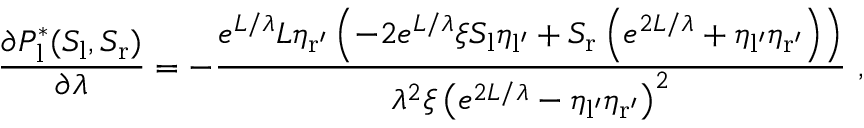Convert formula to latex. <formula><loc_0><loc_0><loc_500><loc_500>\frac { \partial P _ { l } ^ { * } ( S _ { l } , S _ { r } ) } { \partial \lambda } = - \frac { e ^ { L / \lambda } L \eta _ { r ^ { \prime } } \left ( - 2 e ^ { L / \lambda } \xi S _ { l } \eta _ { l ^ { \prime } } + S _ { r } \left ( e ^ { 2 L / \lambda } + \eta _ { l ^ { \prime } } \eta _ { r ^ { \prime } } \right ) \right ) } { \lambda ^ { 2 } \xi \left ( e ^ { 2 L / \lambda } - \eta _ { l ^ { \prime } } \eta _ { r ^ { \prime } } \right ) ^ { 2 } } \ ,</formula> 